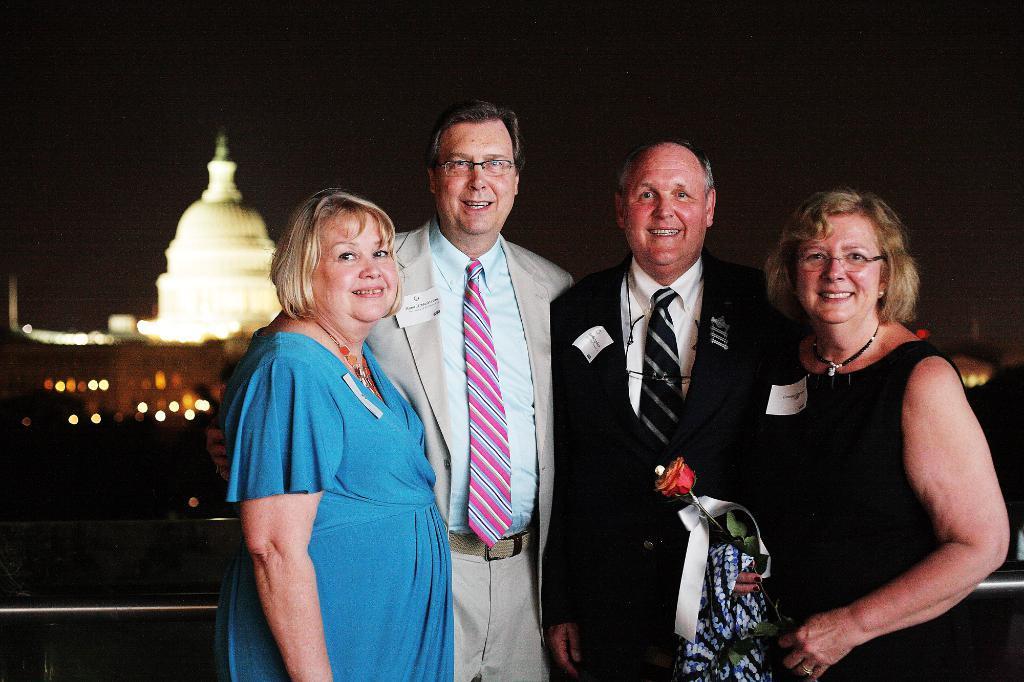Please provide a concise description of this image. In this picture there is a group of old men and women standing in the front, smiling and giving a pose into the camera. Behind there is a white dome building. 